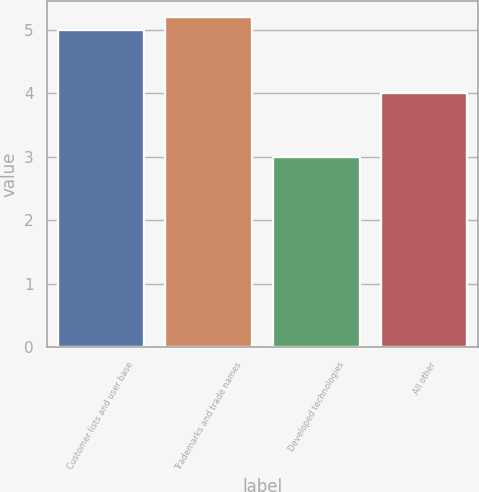Convert chart to OTSL. <chart><loc_0><loc_0><loc_500><loc_500><bar_chart><fcel>Customer lists and user base<fcel>Trademarks and trade names<fcel>Developed technologies<fcel>All other<nl><fcel>5<fcel>5.2<fcel>3<fcel>4<nl></chart> 